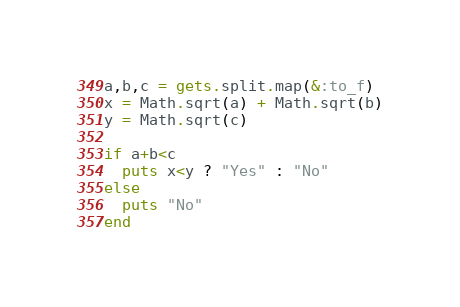<code> <loc_0><loc_0><loc_500><loc_500><_Ruby_>a,b,c = gets.split.map(&:to_f)
x = Math.sqrt(a) + Math.sqrt(b)
y = Math.sqrt(c)

if a+b<c
  puts x<y ? "Yes" : "No"
else
  puts "No"
end
</code> 